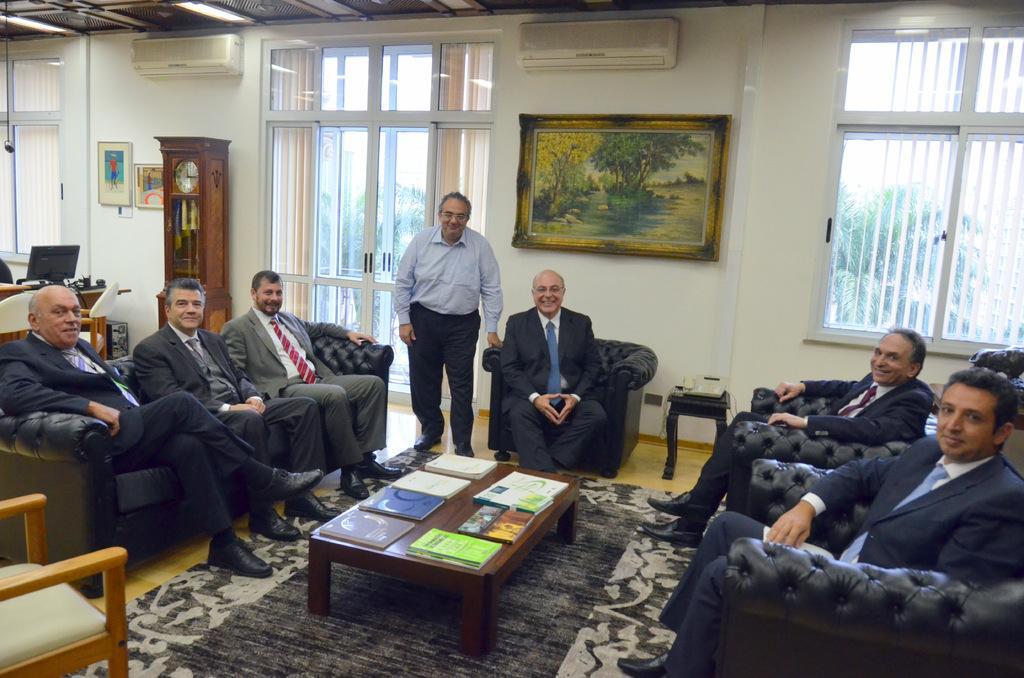Can you describe this image briefly? In this image there are group of persons sitting and at the middle of the image there is a person standing and at the background of the image there are paintings,clock,windows and at the middle of the image there are books on the table. 